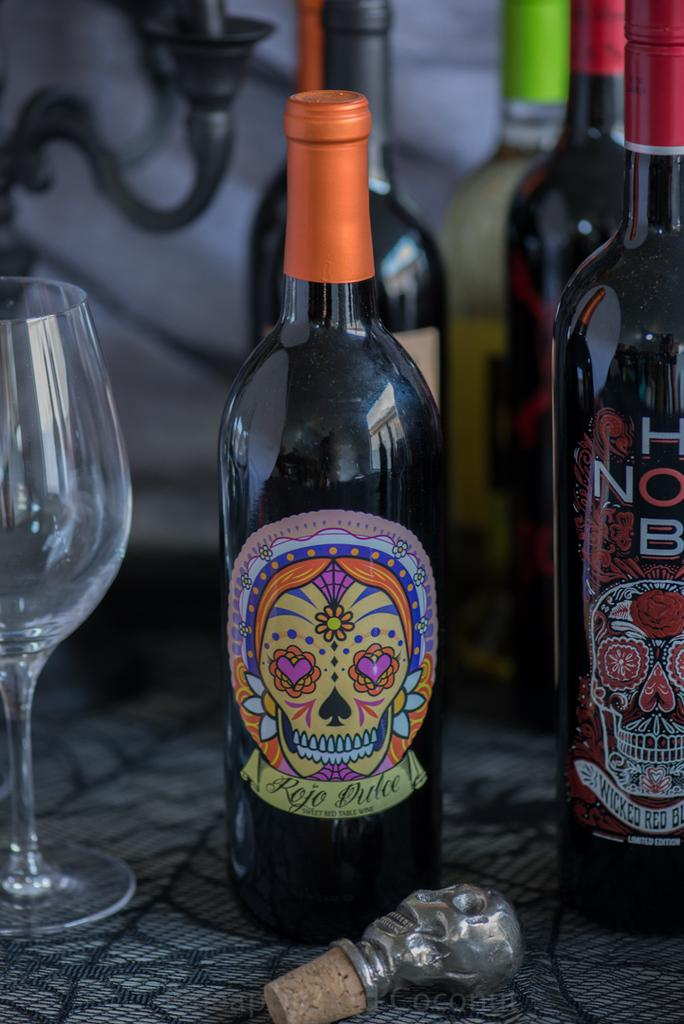What is on the table in the image? There is a wine bottle, a glass, and an opener on the table. What can be seen on the wine bottle? The wine bottle has a sticker on it. What might be used to open the wine bottle? There is an opener on the table that could be used to open the wine bottle. How many daughters are present in the image? There is no mention of a daughter or any people in the image; it only features objects on a table. What type of fowl can be seen in the image? There is no fowl present in the image; it only features a wine bottle, glass, and opener on a table. 